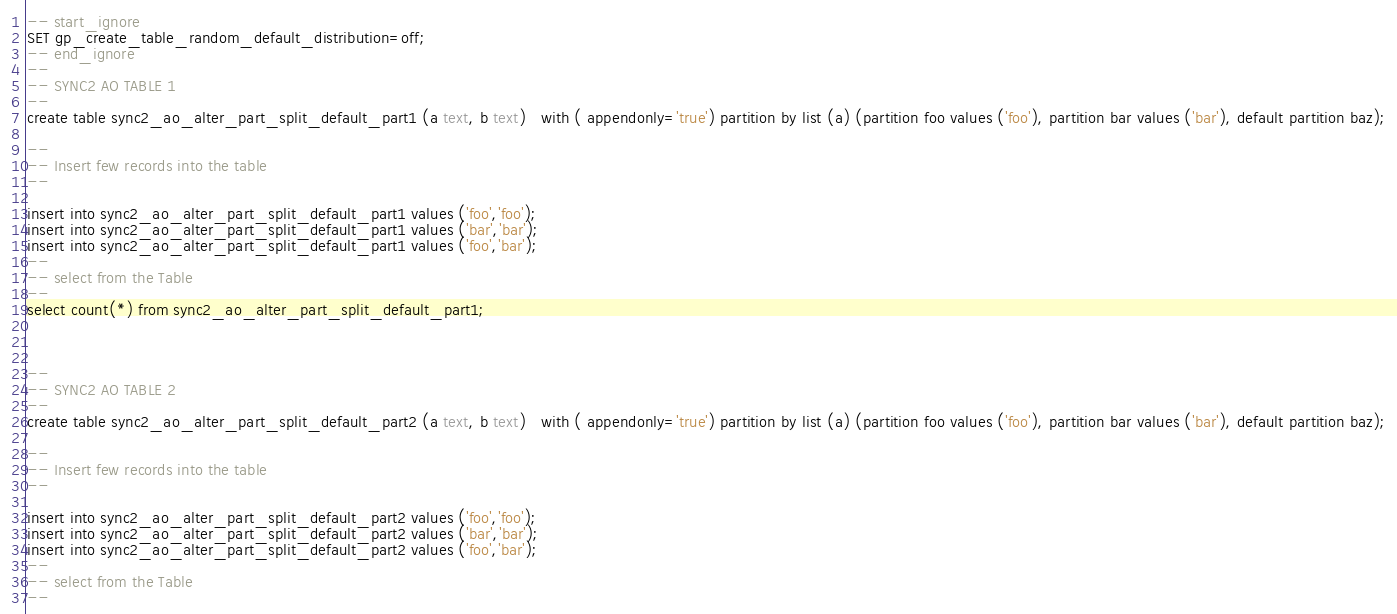Convert code to text. <code><loc_0><loc_0><loc_500><loc_500><_SQL_>-- start_ignore
SET gp_create_table_random_default_distribution=off;
-- end_ignore
--
-- SYNC2 AO TABLE 1
--
create table sync2_ao_alter_part_split_default_part1 (a text, b text)   with ( appendonly='true') partition by list (a) (partition foo values ('foo'), partition bar values ('bar'), default partition baz);

--
-- Insert few records into the table
--

insert into sync2_ao_alter_part_split_default_part1 values ('foo','foo');
insert into sync2_ao_alter_part_split_default_part1 values ('bar','bar');
insert into sync2_ao_alter_part_split_default_part1 values ('foo','bar');
--
-- select from the Table
--
select count(*) from sync2_ao_alter_part_split_default_part1;



--
-- SYNC2 AO TABLE 2
--
create table sync2_ao_alter_part_split_default_part2 (a text, b text)   with ( appendonly='true') partition by list (a) (partition foo values ('foo'), partition bar values ('bar'), default partition baz);

--
-- Insert few records into the table
--

insert into sync2_ao_alter_part_split_default_part2 values ('foo','foo');
insert into sync2_ao_alter_part_split_default_part2 values ('bar','bar');
insert into sync2_ao_alter_part_split_default_part2 values ('foo','bar');
--
-- select from the Table
--</code> 